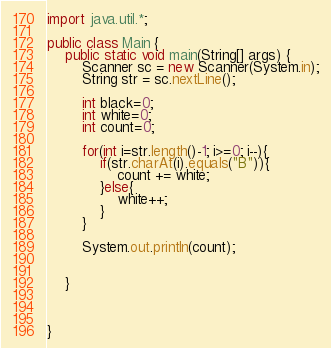Convert code to text. <code><loc_0><loc_0><loc_500><loc_500><_Java_>import java.util.*;
 
public class Main {
    public static void main(String[] args) {
        Scanner sc = new Scanner(System.in);
        String str = sc.nextLine();

        int black=0;
        int white=0;
        int count=0;

        for(int i=str.length()-1; i>=0; i--){
            if(str.charAt(i).equals("B")){
                count += white;
            }else{
                white++;
            }
        }

        System.out.println(count);

 
    }



}</code> 